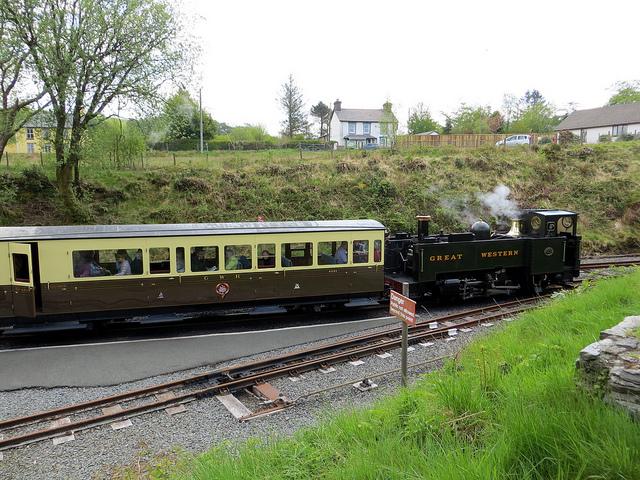Is the train crossing a river?
Quick response, please. No. Where is the train located?
Give a very brief answer. Tracks. Are there passengers on the train?
Short answer required. Yes. What color is the roof of the building on the left?
Answer briefly. Gray. Is this a passenger train?
Quick response, please. Yes. What powers this locomotive?
Keep it brief. Steam. What color is the train?
Be succinct. Yellow and brown. 